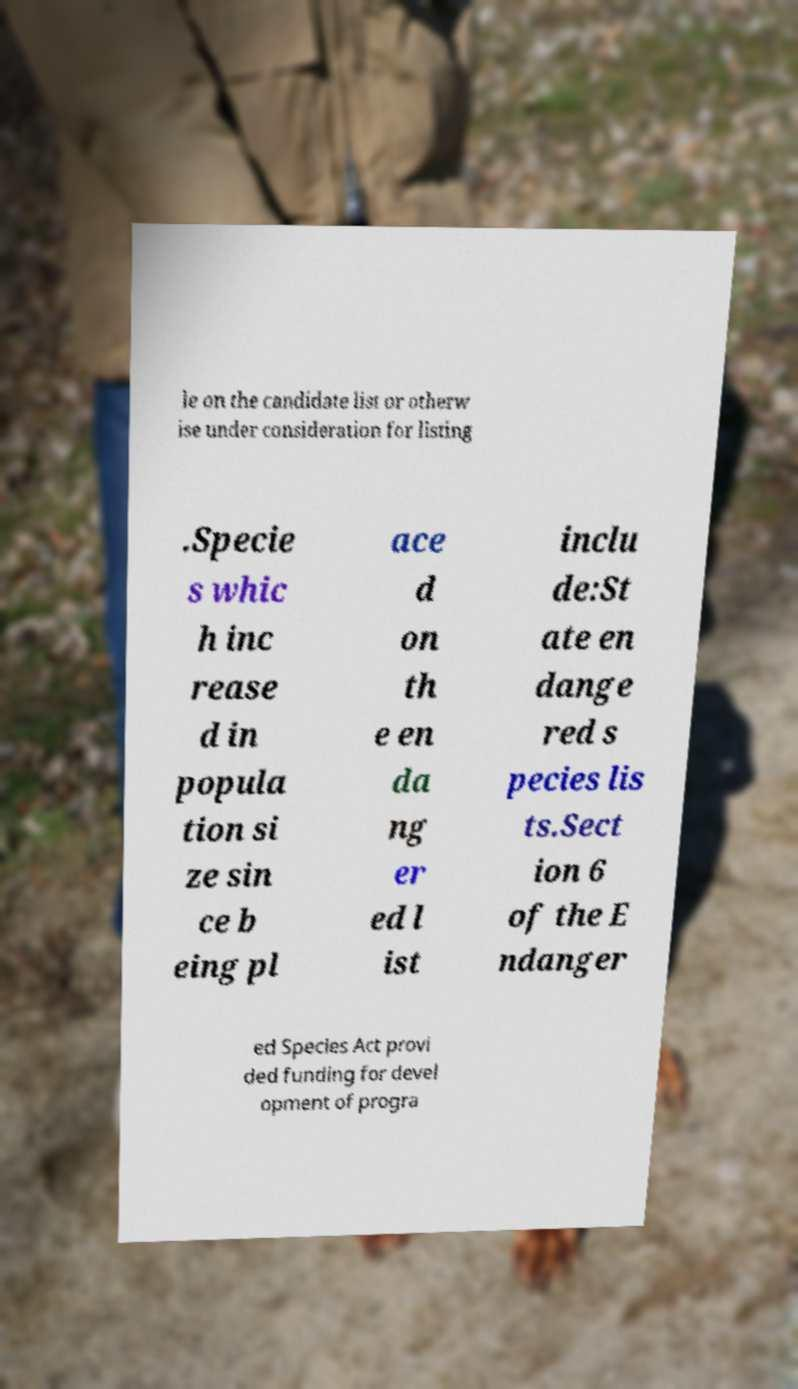Could you extract and type out the text from this image? le on the candidate list or otherw ise under consideration for listing .Specie s whic h inc rease d in popula tion si ze sin ce b eing pl ace d on th e en da ng er ed l ist inclu de:St ate en dange red s pecies lis ts.Sect ion 6 of the E ndanger ed Species Act provi ded funding for devel opment of progra 